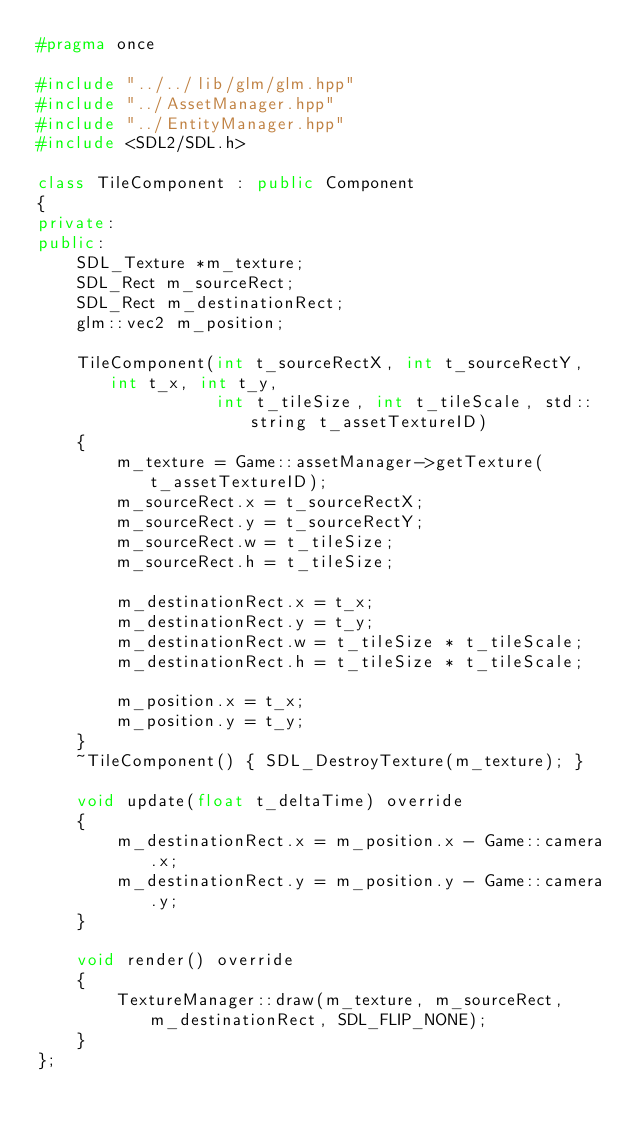<code> <loc_0><loc_0><loc_500><loc_500><_C++_>#pragma once

#include "../../lib/glm/glm.hpp"
#include "../AssetManager.hpp"
#include "../EntityManager.hpp"
#include <SDL2/SDL.h>

class TileComponent : public Component
{
private:
public:
    SDL_Texture *m_texture;
    SDL_Rect m_sourceRect;
    SDL_Rect m_destinationRect;
    glm::vec2 m_position;

    TileComponent(int t_sourceRectX, int t_sourceRectY, int t_x, int t_y,
                  int t_tileSize, int t_tileScale, std::string t_assetTextureID)
    {
        m_texture = Game::assetManager->getTexture(t_assetTextureID);
        m_sourceRect.x = t_sourceRectX;
        m_sourceRect.y = t_sourceRectY;
        m_sourceRect.w = t_tileSize;
        m_sourceRect.h = t_tileSize;

        m_destinationRect.x = t_x;
        m_destinationRect.y = t_y;
        m_destinationRect.w = t_tileSize * t_tileScale;
        m_destinationRect.h = t_tileSize * t_tileScale;

        m_position.x = t_x;
        m_position.y = t_y;
    }
    ~TileComponent() { SDL_DestroyTexture(m_texture); }

    void update(float t_deltaTime) override
    {
        m_destinationRect.x = m_position.x - Game::camera.x;
        m_destinationRect.y = m_position.y - Game::camera.y;
    }

    void render() override
    {
        TextureManager::draw(m_texture, m_sourceRect, m_destinationRect, SDL_FLIP_NONE);
    }
};
</code> 